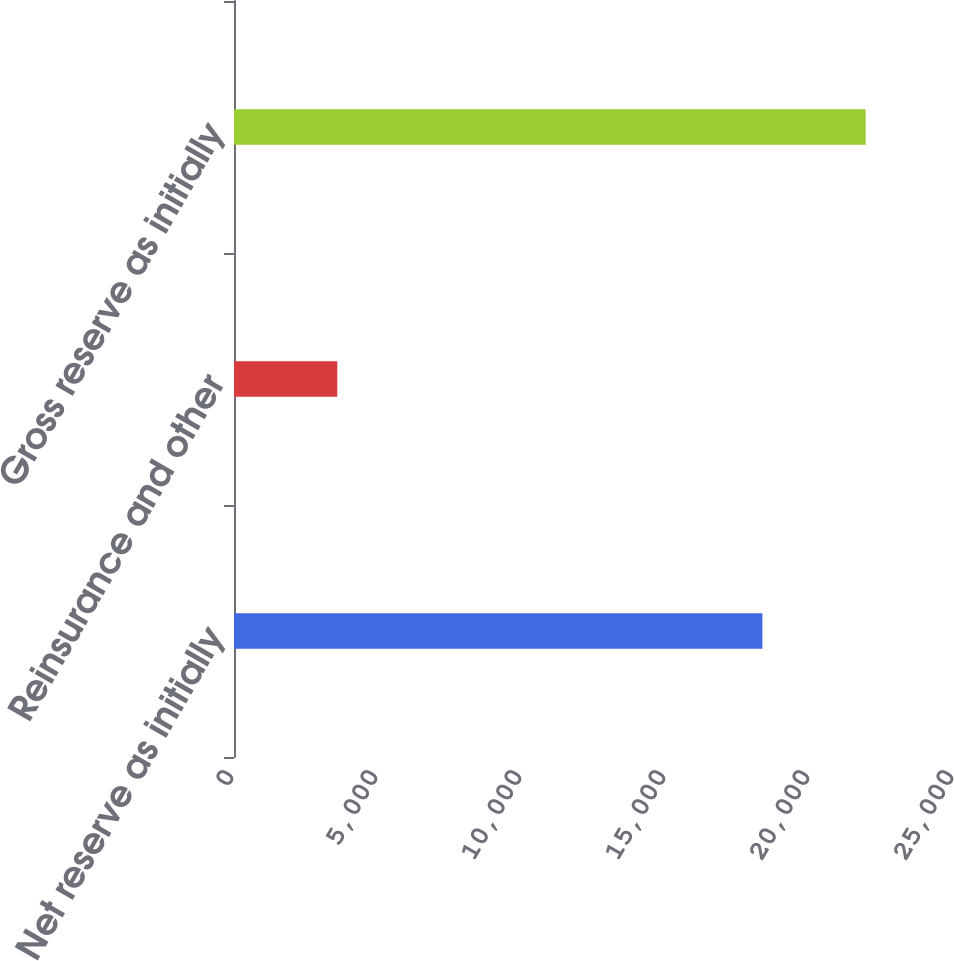Convert chart. <chart><loc_0><loc_0><loc_500><loc_500><bar_chart><fcel>Net reserve as initially<fcel>Reinsurance and other<fcel>Gross reserve as initially<nl><fcel>18347<fcel>3586<fcel>21933<nl></chart> 